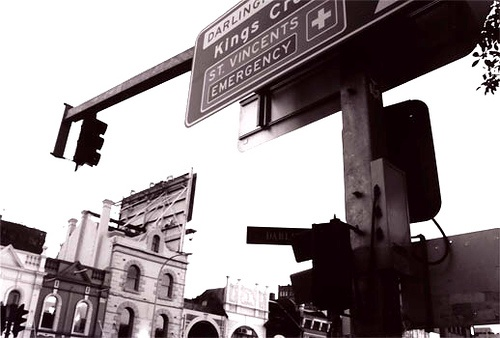Describe the objects in this image and their specific colors. I can see a traffic light in white, black, gray, and darkgray tones in this image. 